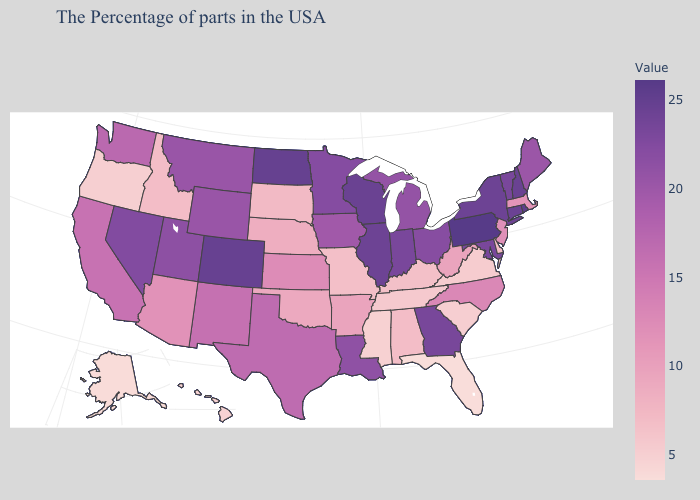Does Pennsylvania have the highest value in the USA?
Give a very brief answer. Yes. Does Tennessee have a lower value than Maine?
Concise answer only. Yes. Which states have the lowest value in the USA?
Answer briefly. Florida. Does Nebraska have a higher value than Kansas?
Be succinct. No. Among the states that border Illinois , does Kentucky have the lowest value?
Concise answer only. Yes. Is the legend a continuous bar?
Quick response, please. Yes. 